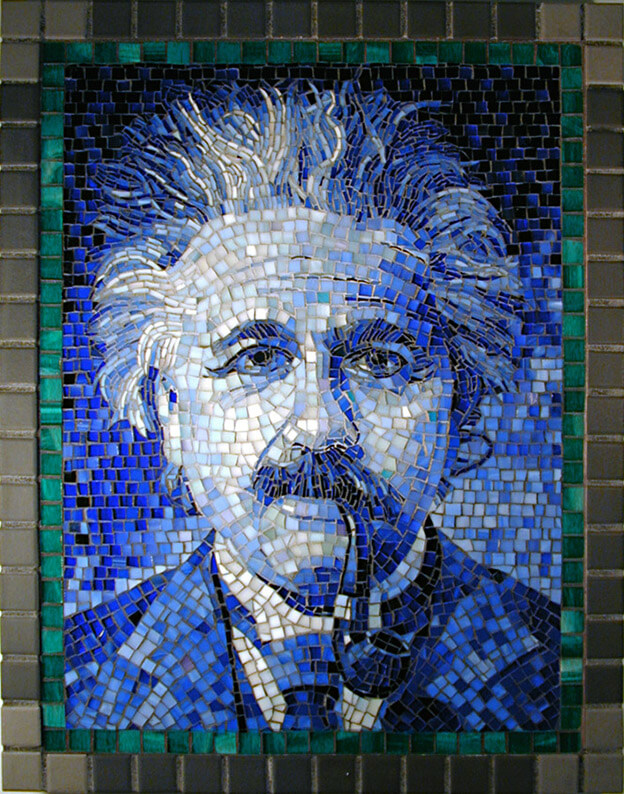How does the choice of lighting in the photograph of the mosaic affect the viewer's perception? The lighting captured in the photograph subtly enhances the mosaic's visual impact by casting a gentle illumination that highlights the different hues within the portrait. This particular lighting condition adds depth to the colors, making the blues more vibrant which could symbolically echo the liveliness of the figure's thoughts. The lighter areas appear more illuminated, drawing attention to specific aspects of the face, such as the eyes and forehead, which are traditionally associated with insight and intellect. Consequently, the viewer might perceive the figure as not only intellectually profound but also as possessing a clarity and foresight that are visually emphasized by the strategic use of lighting. 